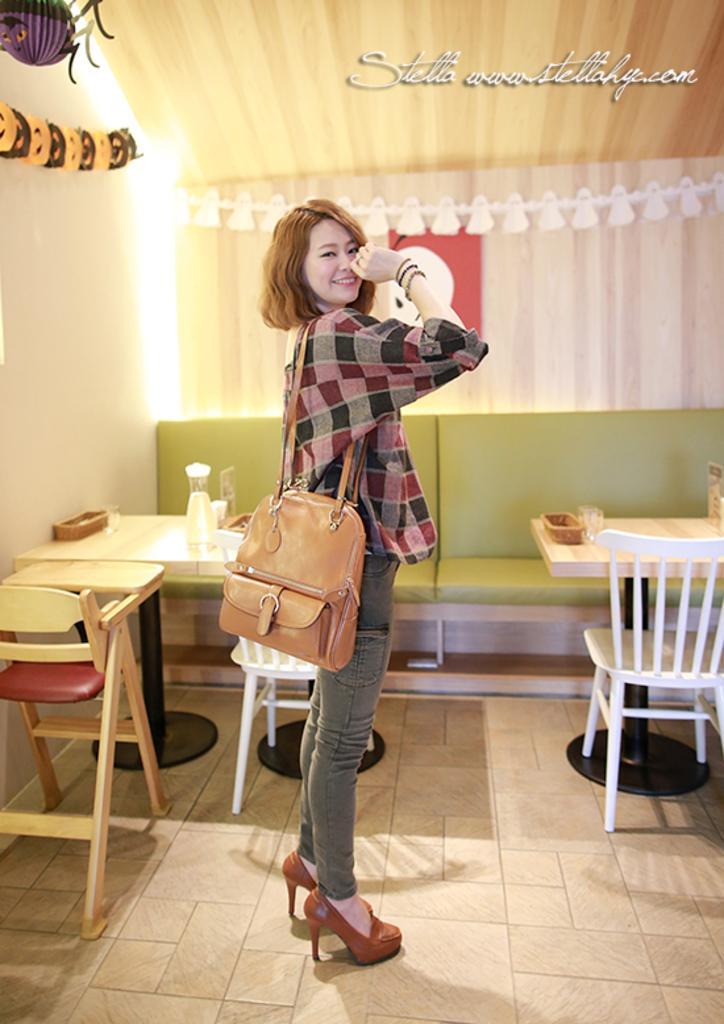Could you give a brief overview of what you see in this image? In this picture we can see a women with short hair and she is carrying a bag on her shoulder and she holds a beautiful smile on her face. This is a floor. And on the floor we can see empty chairs and tables and on the table we can see bottle and glasses. This is a sofa. This is a wall. 